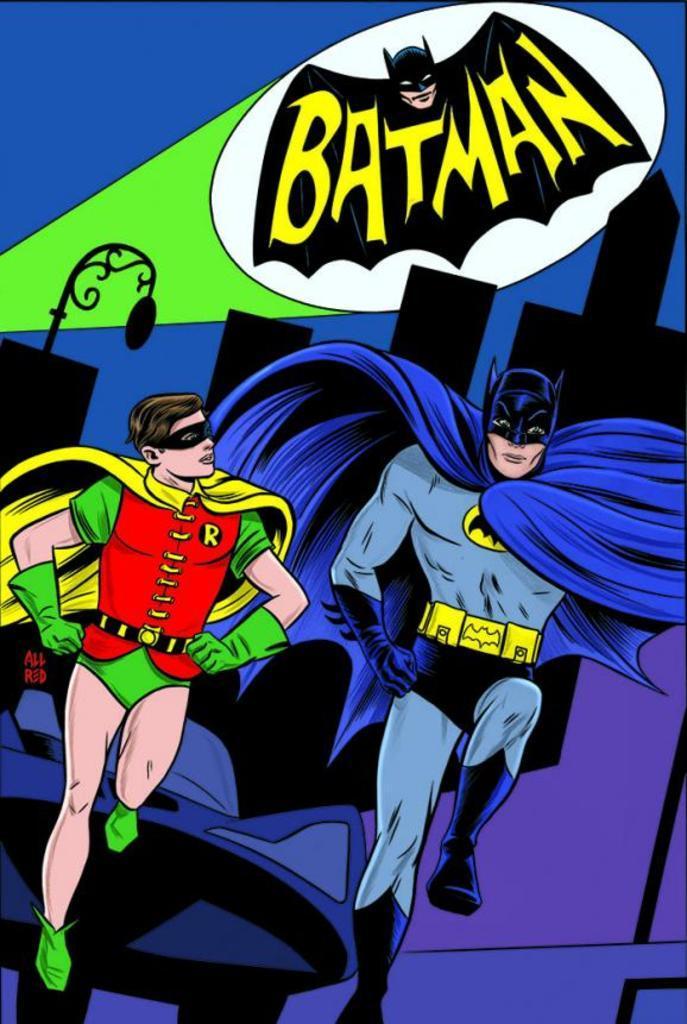Please provide a concise description of this image. This picture contains the cartoon of the men who are wearing blue and red dresses. At the top of the picture, it is written as "BATMAN". In the background, it is blue in color. 